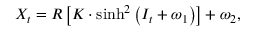Convert formula to latex. <formula><loc_0><loc_0><loc_500><loc_500>X _ { t } = R \left [ K \cdot \sinh ^ { 2 } \left ( I _ { t } + \omega _ { 1 } \right ) \right ] + \omega _ { 2 } ,</formula> 